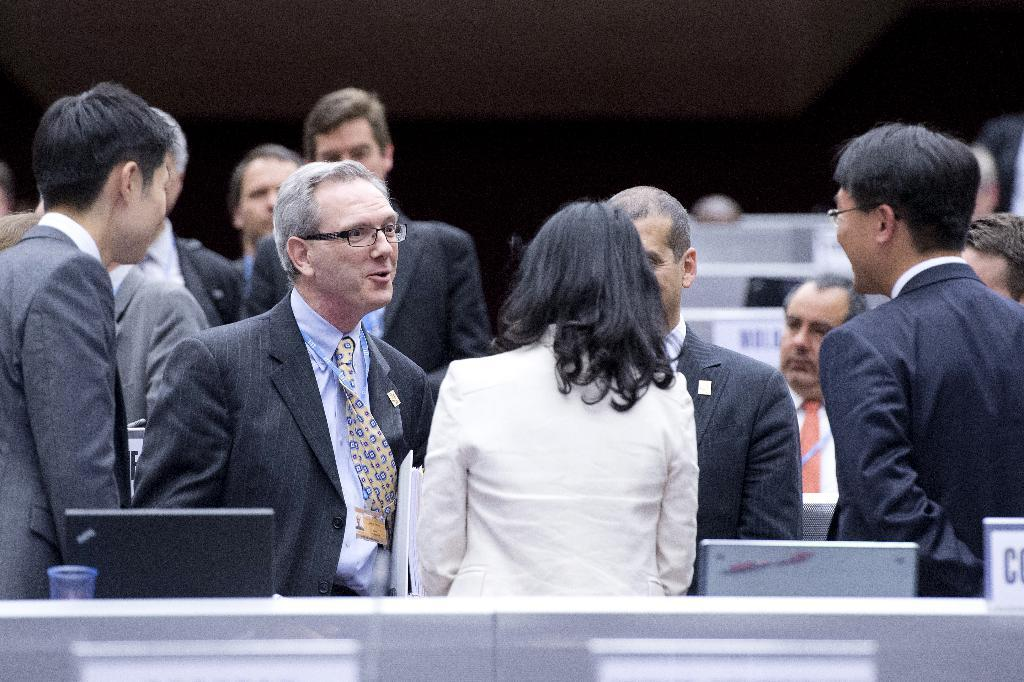What are the people in the image doing? The persons standing on the floor are likely engaged in some activity or standing near the desks. What objects can be seen on the desk in the image? Laptops are present on a desk in the image. What can be seen in the background of the image? There are desks and a wall visible in the background of the image. Who is the creator of the reward mentioned in the image? There is no mention of a reward or a creator in the image. 